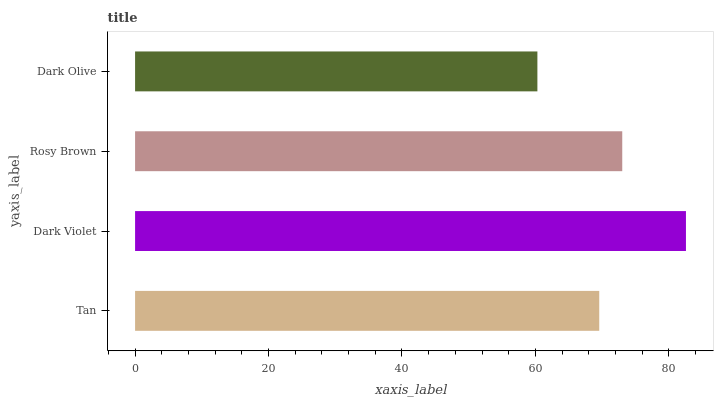Is Dark Olive the minimum?
Answer yes or no. Yes. Is Dark Violet the maximum?
Answer yes or no. Yes. Is Rosy Brown the minimum?
Answer yes or no. No. Is Rosy Brown the maximum?
Answer yes or no. No. Is Dark Violet greater than Rosy Brown?
Answer yes or no. Yes. Is Rosy Brown less than Dark Violet?
Answer yes or no. Yes. Is Rosy Brown greater than Dark Violet?
Answer yes or no. No. Is Dark Violet less than Rosy Brown?
Answer yes or no. No. Is Rosy Brown the high median?
Answer yes or no. Yes. Is Tan the low median?
Answer yes or no. Yes. Is Tan the high median?
Answer yes or no. No. Is Dark Violet the low median?
Answer yes or no. No. 